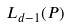<formula> <loc_0><loc_0><loc_500><loc_500>L _ { d - 1 } ( P )</formula> 